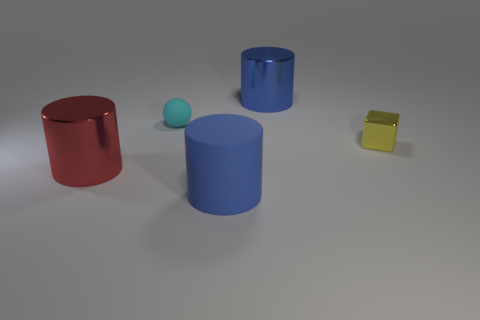What could be the purpose of this collection of objects? The collection of objects appears to be part of a simple setup, perhaps for a basic study of geometry or a visual exercise in color theory. The distinct primary colors and simple shapes could serve as an educational aid for teaching children about shapes, color recognition, and spatial relations, or as part of a design study in a computer graphics context. 